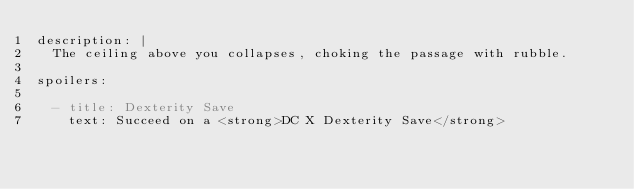<code> <loc_0><loc_0><loc_500><loc_500><_YAML_>description: |
  The ceiling above you collapses, choking the passage with rubble.

spoilers:

  - title: Dexterity Save
    text: Succeed on a <strong>DC X Dexterity Save</strong>
</code> 